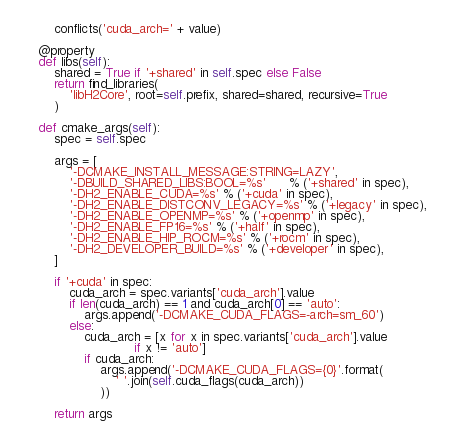<code> <loc_0><loc_0><loc_500><loc_500><_Python_>        conflicts('cuda_arch=' + value)

    @property
    def libs(self):
        shared = True if '+shared' in self.spec else False
        return find_libraries(
            'libH2Core', root=self.prefix, shared=shared, recursive=True
        )

    def cmake_args(self):
        spec = self.spec

        args = [
            '-DCMAKE_INSTALL_MESSAGE:STRING=LAZY',
            '-DBUILD_SHARED_LIBS:BOOL=%s'      % ('+shared' in spec),
            '-DH2_ENABLE_CUDA=%s' % ('+cuda' in spec),
            '-DH2_ENABLE_DISTCONV_LEGACY=%s' % ('+legacy' in spec),
            '-DH2_ENABLE_OPENMP=%s' % ('+openmp' in spec),
            '-DH2_ENABLE_FP16=%s' % ('+half' in spec),
            '-DH2_ENABLE_HIP_ROCM=%s' % ('+rocm' in spec),
            '-DH2_DEVELOPER_BUILD=%s' % ('+developer' in spec),
        ]

        if '+cuda' in spec:
            cuda_arch = spec.variants['cuda_arch'].value
            if len(cuda_arch) == 1 and cuda_arch[0] == 'auto':
                args.append('-DCMAKE_CUDA_FLAGS=-arch=sm_60')
            else:
                cuda_arch = [x for x in spec.variants['cuda_arch'].value
                             if x != 'auto']
                if cuda_arch:
                    args.append('-DCMAKE_CUDA_FLAGS={0}'.format(
                        ' '.join(self.cuda_flags(cuda_arch))
                    ))

        return args
</code> 